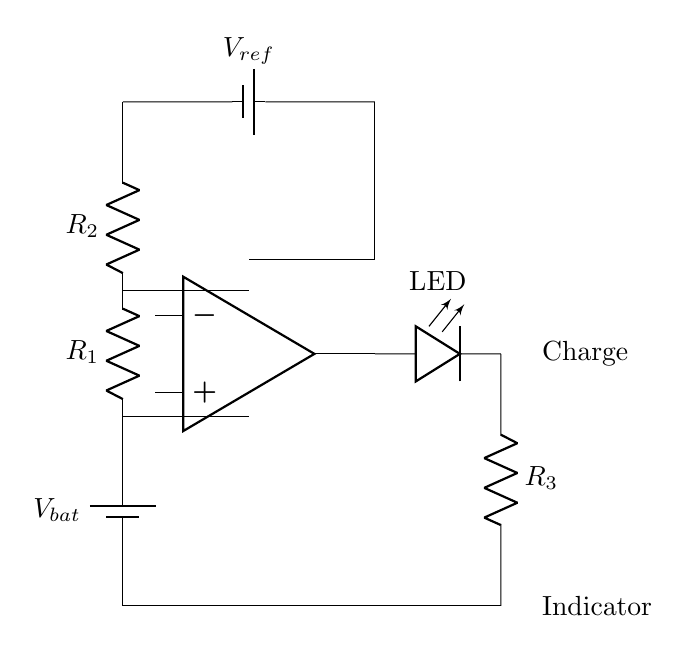What type of circuit is represented? The circuit represents a battery charge indicator. It indicates when a battery is charging by using a comparator and a light-emitting diode (LED).
Answer: Battery charge indicator What is the purpose of the resistors R1 and R2? Resistors R1 and R2 form a voltage divider that helps set the reference voltage as a function of the input voltage. This setup allows the comparator to determine if the battery is charging based on voltage levels.
Answer: Voltage divider What is the reference voltage labeled as? The reference voltage in the circuit is labeled as V_ref. It provides a stable reference point for the comparator to compare against the voltage from the voltage divider formed by R1 and R2.
Answer: V_ref What component indicates charging status? The component that indicates the charging status is the LED. When the circuit detects a voltage level indicating charging, the LED lights up.
Answer: LED Which component acts as a comparison tool in the circuit? The component that acts as a comparison tool in the circuit is the op-amp (comparator). It compares the output from the voltage divider with the reference voltage to signal whether the battery is charging.
Answer: Op-amp What is the role of the resistor R3? Resistor R3 limits the current through the LED to prevent it from burning out, ensuring that the LED operates within its safe current range while indicating the charging status.
Answer: Current limiter 